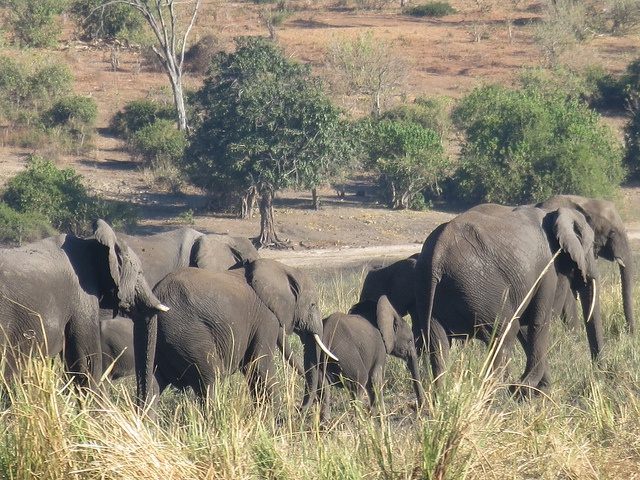Describe the objects in this image and their specific colors. I can see elephant in gray, black, and darkgray tones, elephant in gray, black, and darkgray tones, elephant in gray, darkgray, and black tones, elephant in gray and darkgray tones, and elephant in gray, black, and darkgray tones in this image. 